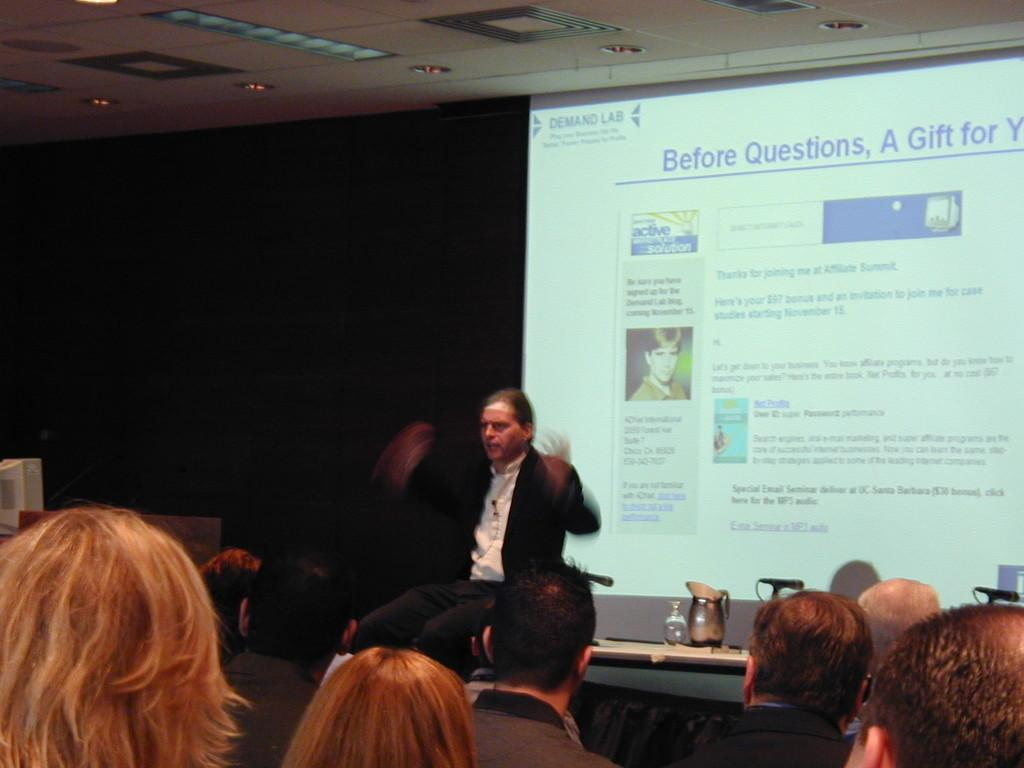Who or what is present in the image? There are people in the image. What is one of the structures visible in the image? There is a wall in the image. What piece of furniture can be seen in the image? There is a table in the image. What type of object is present on the table? There are mugs on the table. What is the lighting condition in the image? The image is slightly dark. What word is being spelled out by the people in the image? There is no word being spelled out by the people in the image; they are not engaged in any such activity. 